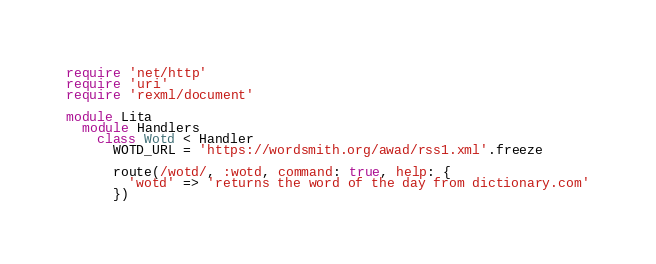Convert code to text. <code><loc_0><loc_0><loc_500><loc_500><_Ruby_>require 'net/http'
require 'uri'
require 'rexml/document'

module Lita
  module Handlers
    class Wotd < Handler
      WOTD_URL = 'https://wordsmith.org/awad/rss1.xml'.freeze

      route(/wotd/, :wotd, command: true, help: {
        'wotd' => 'returns the word of the day from dictionary.com'
      })
</code> 